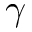<formula> <loc_0><loc_0><loc_500><loc_500>\gamma</formula> 